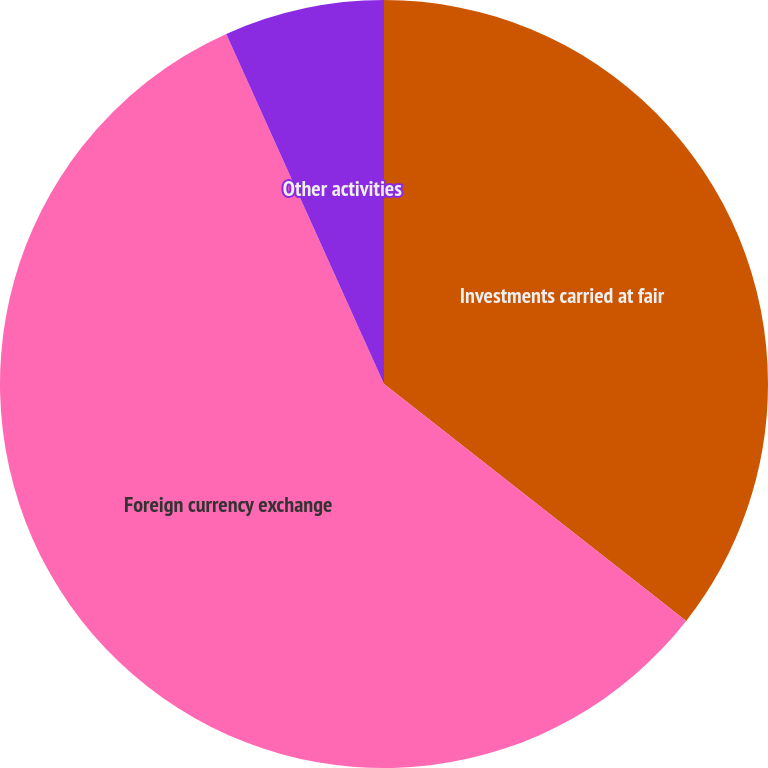Convert chart to OTSL. <chart><loc_0><loc_0><loc_500><loc_500><pie_chart><fcel>Investments carried at fair<fcel>Foreign currency exchange<fcel>Other activities<nl><fcel>35.58%<fcel>57.68%<fcel>6.74%<nl></chart> 